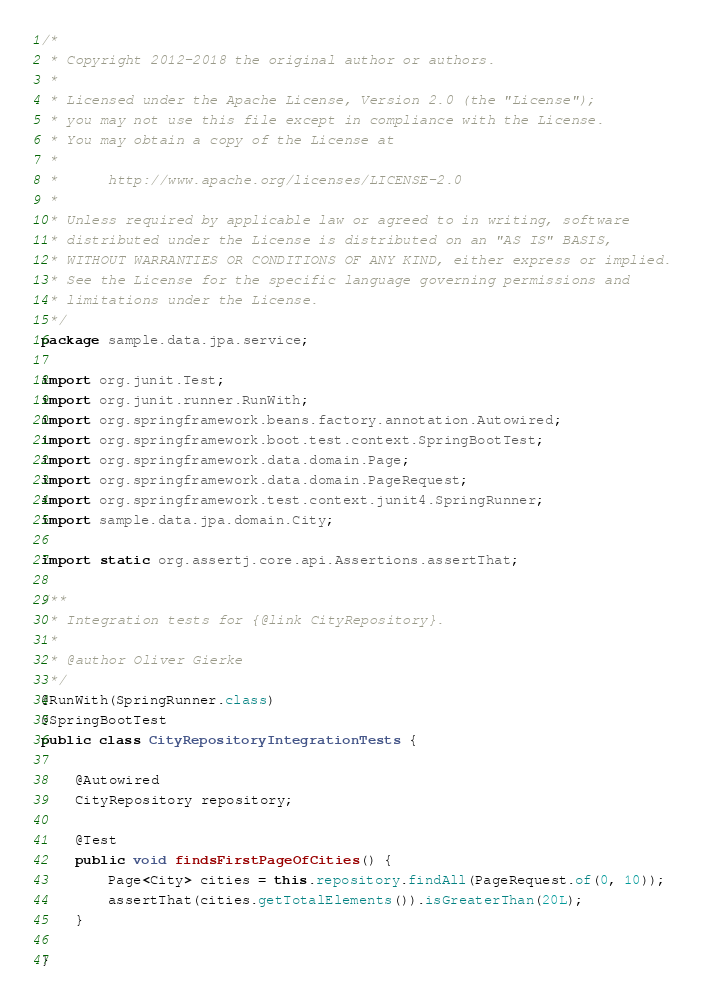<code> <loc_0><loc_0><loc_500><loc_500><_Java_>/*
 * Copyright 2012-2018 the original author or authors.
 *
 * Licensed under the Apache License, Version 2.0 (the "License");
 * you may not use this file except in compliance with the License.
 * You may obtain a copy of the License at
 *
 *      http://www.apache.org/licenses/LICENSE-2.0
 *
 * Unless required by applicable law or agreed to in writing, software
 * distributed under the License is distributed on an "AS IS" BASIS,
 * WITHOUT WARRANTIES OR CONDITIONS OF ANY KIND, either express or implied.
 * See the License for the specific language governing permissions and
 * limitations under the License.
 */
package sample.data.jpa.service;

import org.junit.Test;
import org.junit.runner.RunWith;
import org.springframework.beans.factory.annotation.Autowired;
import org.springframework.boot.test.context.SpringBootTest;
import org.springframework.data.domain.Page;
import org.springframework.data.domain.PageRequest;
import org.springframework.test.context.junit4.SpringRunner;
import sample.data.jpa.domain.City;

import static org.assertj.core.api.Assertions.assertThat;

/**
 * Integration tests for {@link CityRepository}.
 *
 * @author Oliver Gierke
 */
@RunWith(SpringRunner.class)
@SpringBootTest
public class CityRepositoryIntegrationTests {

	@Autowired
	CityRepository repository;

	@Test
	public void findsFirstPageOfCities() {
		Page<City> cities = this.repository.findAll(PageRequest.of(0, 10));
		assertThat(cities.getTotalElements()).isGreaterThan(20L);
	}

}
</code> 